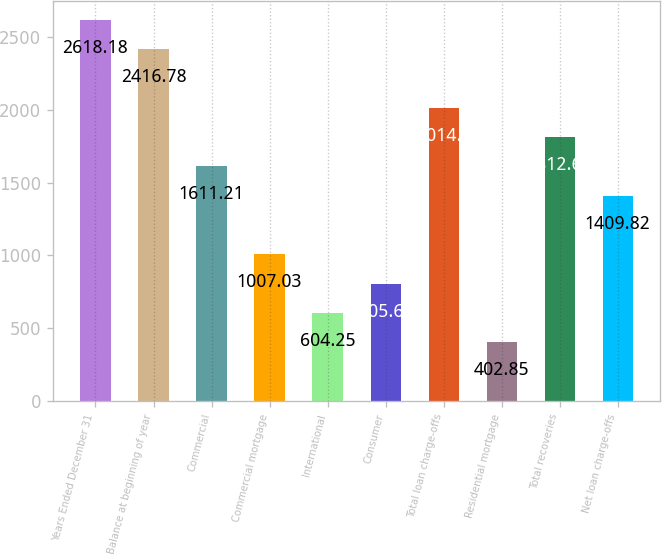Convert chart to OTSL. <chart><loc_0><loc_0><loc_500><loc_500><bar_chart><fcel>Years Ended December 31<fcel>Balance at beginning of year<fcel>Commercial<fcel>Commercial mortgage<fcel>International<fcel>Consumer<fcel>Total loan charge-offs<fcel>Residential mortgage<fcel>Total recoveries<fcel>Net loan charge-offs<nl><fcel>2618.18<fcel>2416.78<fcel>1611.21<fcel>1007.03<fcel>604.25<fcel>805.64<fcel>2014<fcel>402.85<fcel>1812.61<fcel>1409.82<nl></chart> 